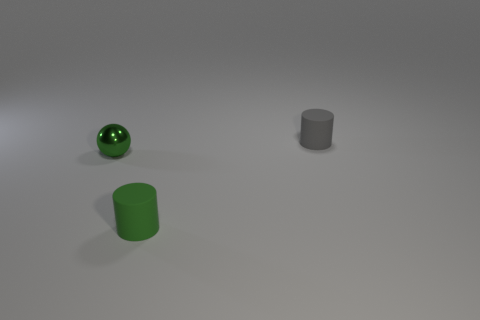Is there anything else that has the same material as the small green ball?
Your answer should be very brief. No. What color is the thing that is left of the gray object and behind the small green cylinder?
Your answer should be very brief. Green. What number of gray matte cubes are the same size as the gray rubber cylinder?
Your answer should be compact. 0. What is the tiny sphere made of?
Give a very brief answer. Metal. Are there any small matte objects in front of the gray thing?
Your answer should be compact. Yes. There is another cylinder that is the same material as the green cylinder; what is its size?
Your response must be concise. Small. What number of tiny things are the same color as the sphere?
Keep it short and to the point. 1. Is the number of cylinders that are in front of the shiny sphere less than the number of small green things in front of the gray cylinder?
Your answer should be very brief. Yes. Is there another cylinder made of the same material as the tiny gray cylinder?
Keep it short and to the point. Yes. Do the gray object and the small green cylinder have the same material?
Your answer should be very brief. Yes. 